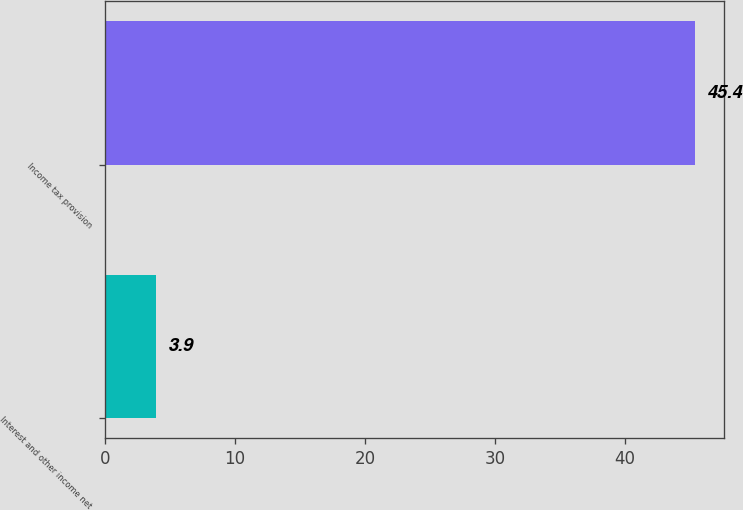Convert chart. <chart><loc_0><loc_0><loc_500><loc_500><bar_chart><fcel>Interest and other income net<fcel>Income tax provision<nl><fcel>3.9<fcel>45.4<nl></chart> 